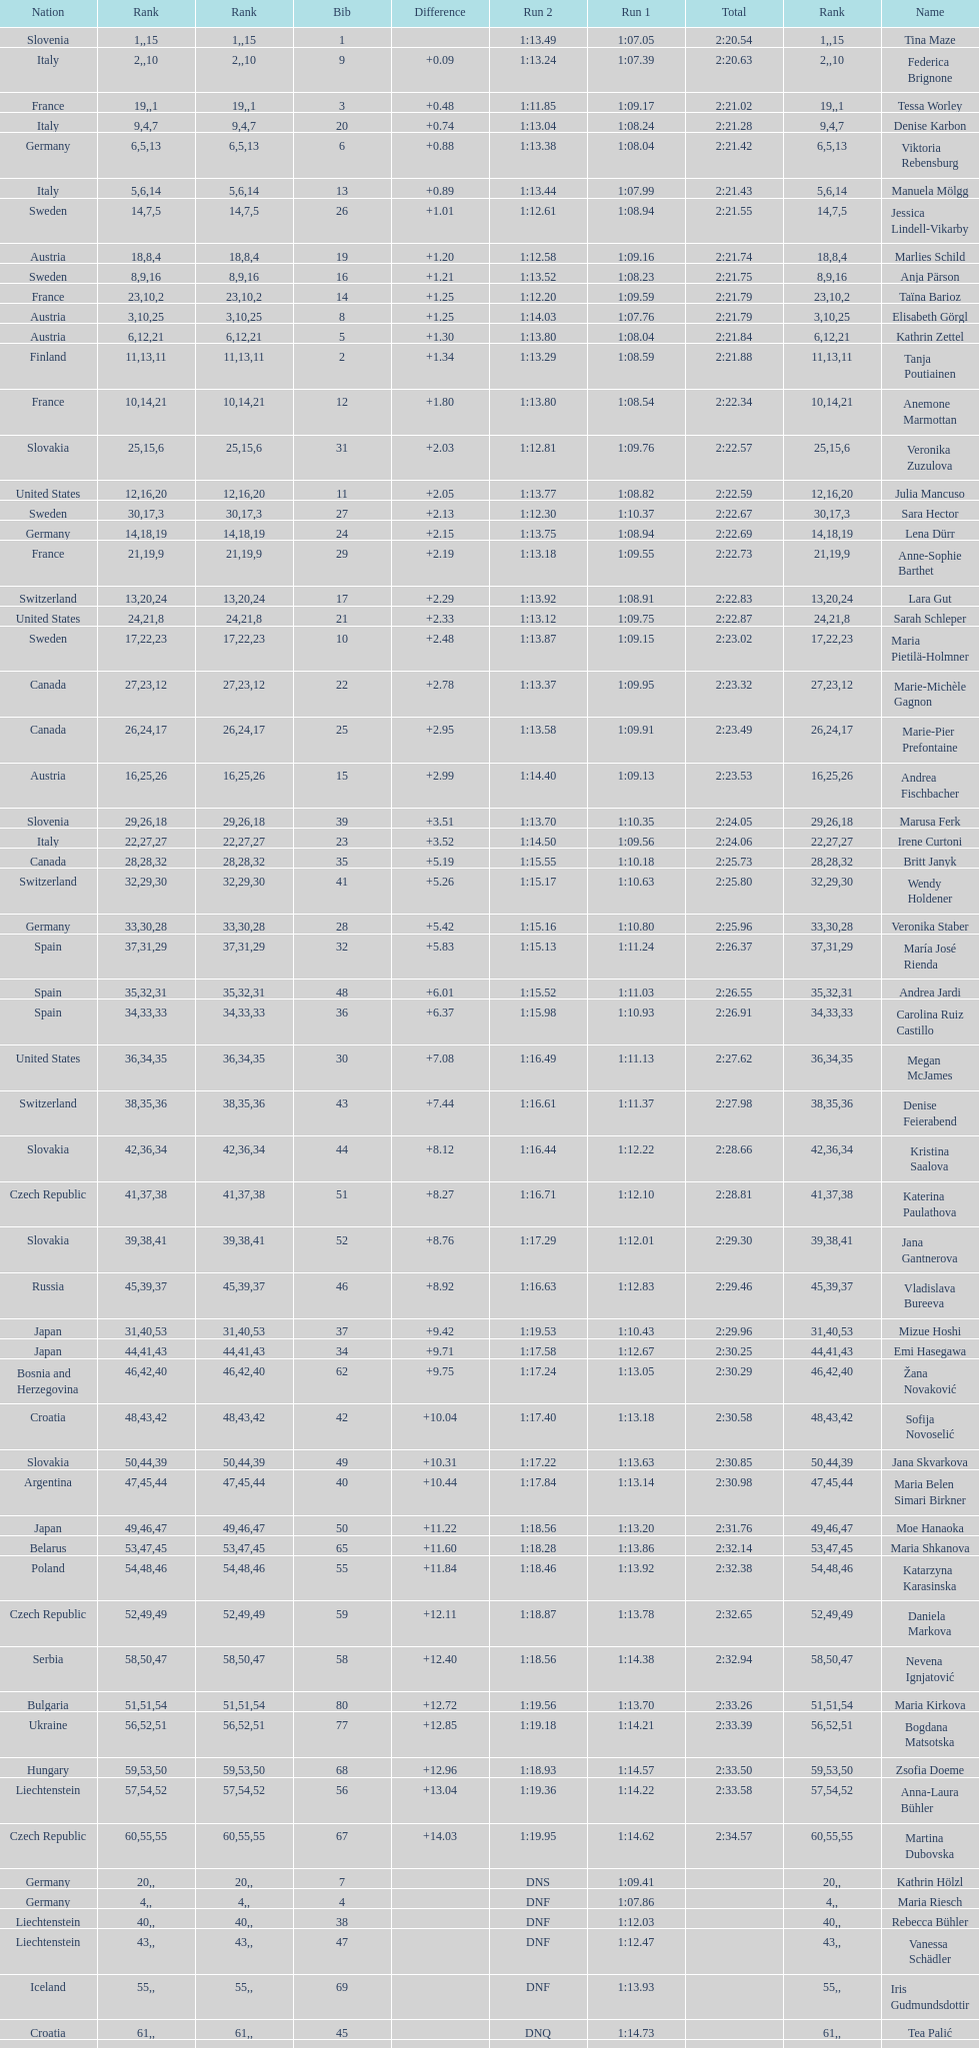Who ranked next after federica brignone? Tessa Worley. 